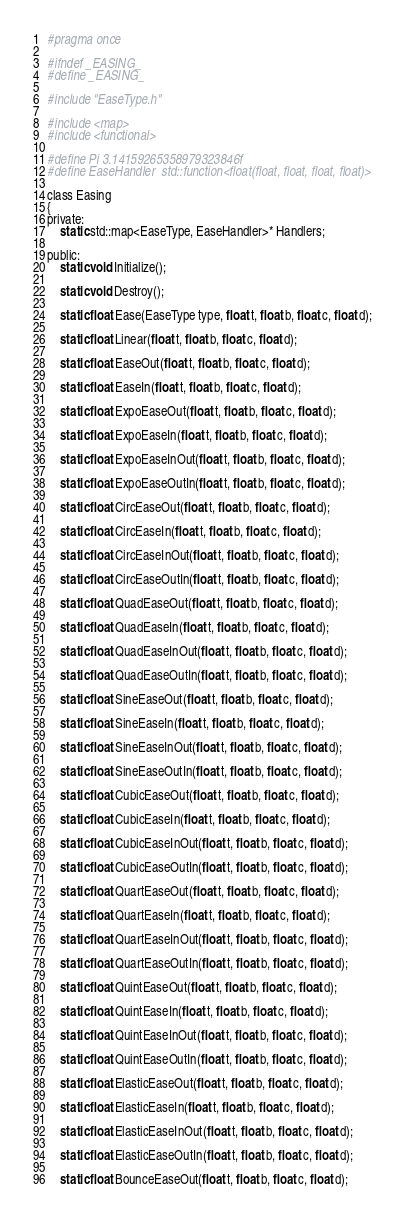Convert code to text. <code><loc_0><loc_0><loc_500><loc_500><_C_>#pragma once

#ifndef _EASING_
#define _EASING_

#include "EaseType.h"

#include <map>
#include <functional>

#define Pi 3.14159265358979323846f
#define EaseHandler	std::function<float(float, float, float, float)>

class Easing
{
private:
	static std::map<EaseType, EaseHandler>* Handlers;

public:
	static void Initialize();

	static void Destroy();

	static float Ease(EaseType type, float t, float b, float c, float d);

	static float Linear(float t, float b, float c, float d);

	static float EaseOut(float t, float b, float c, float d);

	static float EaseIn(float t, float b, float c, float d);

	static float ExpoEaseOut(float t, float b, float c, float d);

	static float ExpoEaseIn(float t, float b, float c, float d);

	static float ExpoEaseInOut(float t, float b, float c, float d);

	static float ExpoEaseOutIn(float t, float b, float c, float d);

	static float CircEaseOut(float t, float b, float c, float d);

	static float CircEaseIn(float t, float b, float c, float d);

	static float CircEaseInOut(float t, float b, float c, float d);

	static float CircEaseOutIn(float t, float b, float c, float d);

	static float QuadEaseOut(float t, float b, float c, float d);

	static float QuadEaseIn(float t, float b, float c, float d);

	static float QuadEaseInOut(float t, float b, float c, float d);

	static float QuadEaseOutIn(float t, float b, float c, float d);

	static float SineEaseOut(float t, float b, float c, float d);

	static float SineEaseIn(float t, float b, float c, float d);

	static float SineEaseInOut(float t, float b, float c, float d);

	static float SineEaseOutIn(float t, float b, float c, float d);

	static float CubicEaseOut(float t, float b, float c, float d);

	static float CubicEaseIn(float t, float b, float c, float d);

	static float CubicEaseInOut(float t, float b, float c, float d);

	static float CubicEaseOutIn(float t, float b, float c, float d);

	static float QuartEaseOut(float t, float b, float c, float d);

	static float QuartEaseIn(float t, float b, float c, float d);

	static float QuartEaseInOut(float t, float b, float c, float d);

	static float QuartEaseOutIn(float t, float b, float c, float d);

	static float QuintEaseOut(float t, float b, float c, float d);

	static float QuintEaseIn(float t, float b, float c, float d);

	static float QuintEaseInOut(float t, float b, float c, float d);

	static float QuintEaseOutIn(float t, float b, float c, float d);

	static float ElasticEaseOut(float t, float b, float c, float d);

	static float ElasticEaseIn(float t, float b, float c, float d);

	static float ElasticEaseInOut(float t, float b, float c, float d);

	static float ElasticEaseOutIn(float t, float b, float c, float d);

	static float BounceEaseOut(float t, float b, float c, float d);
</code> 